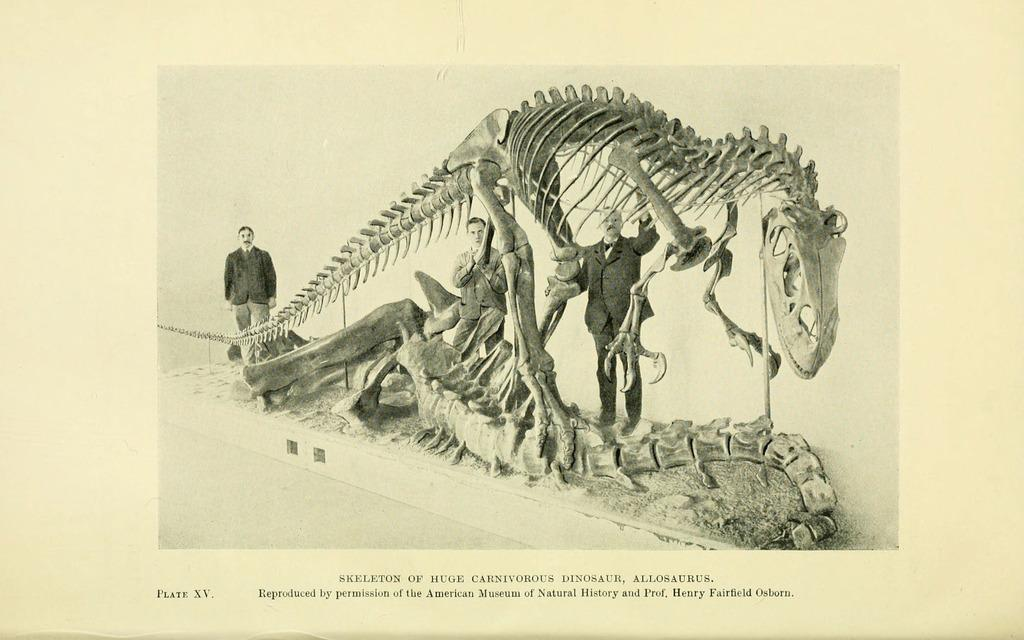What is the main subject of the paper in the image? The paper contains a picture of people standing. What are the people in the picture wearing? The people in the picture are wearing clothes. What type of sculpture can be seen in the image? There is a bone sculpture of a dinosaur in the image. What else is visible on the paper besides the picture of people? There is text visible in the image. What type of bird can be seen flying in the image? There is no bird visible in the image; it features a paper with a picture of people, text, and a bone sculpture of a dinosaur. 